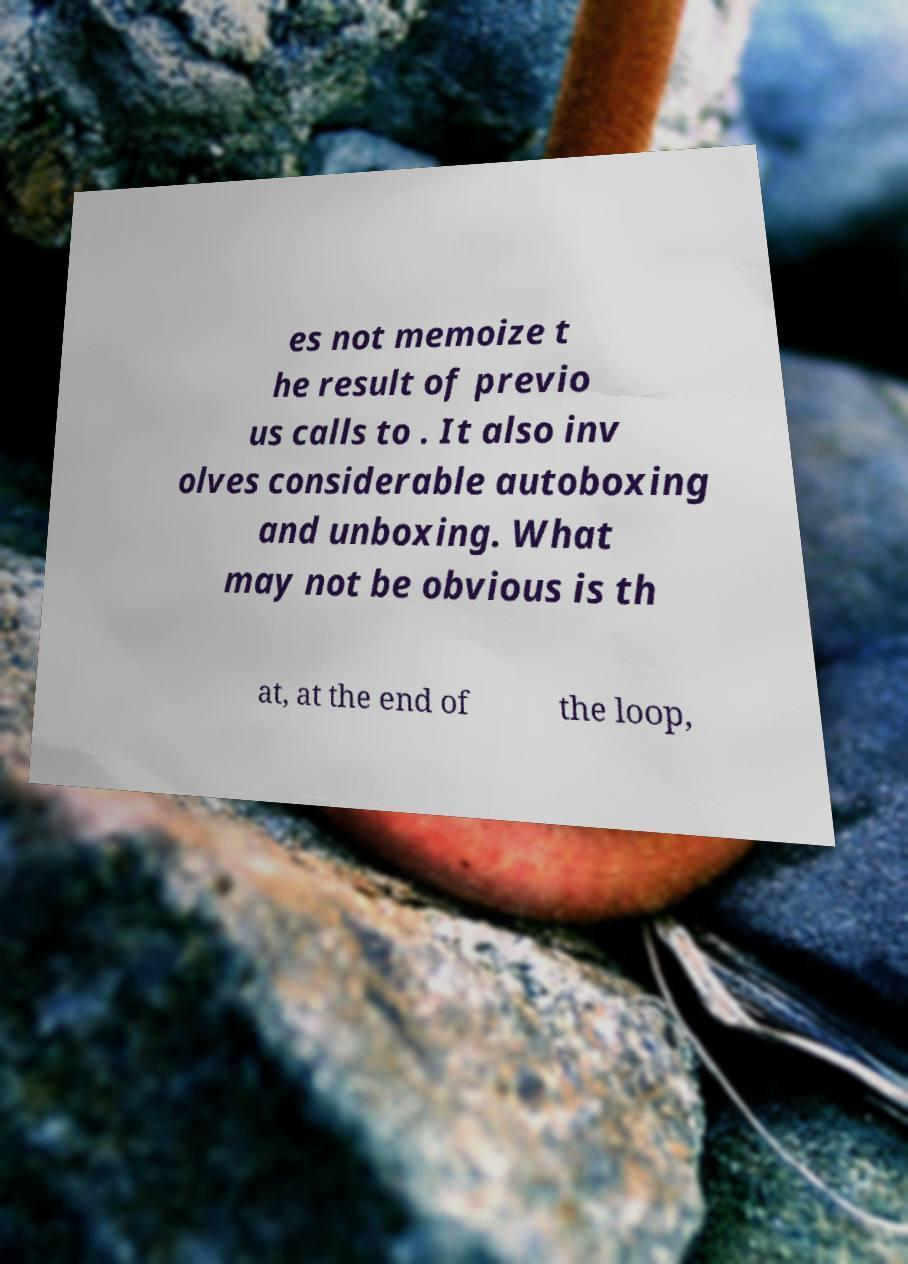Please read and relay the text visible in this image. What does it say? es not memoize t he result of previo us calls to . It also inv olves considerable autoboxing and unboxing. What may not be obvious is th at, at the end of the loop, 